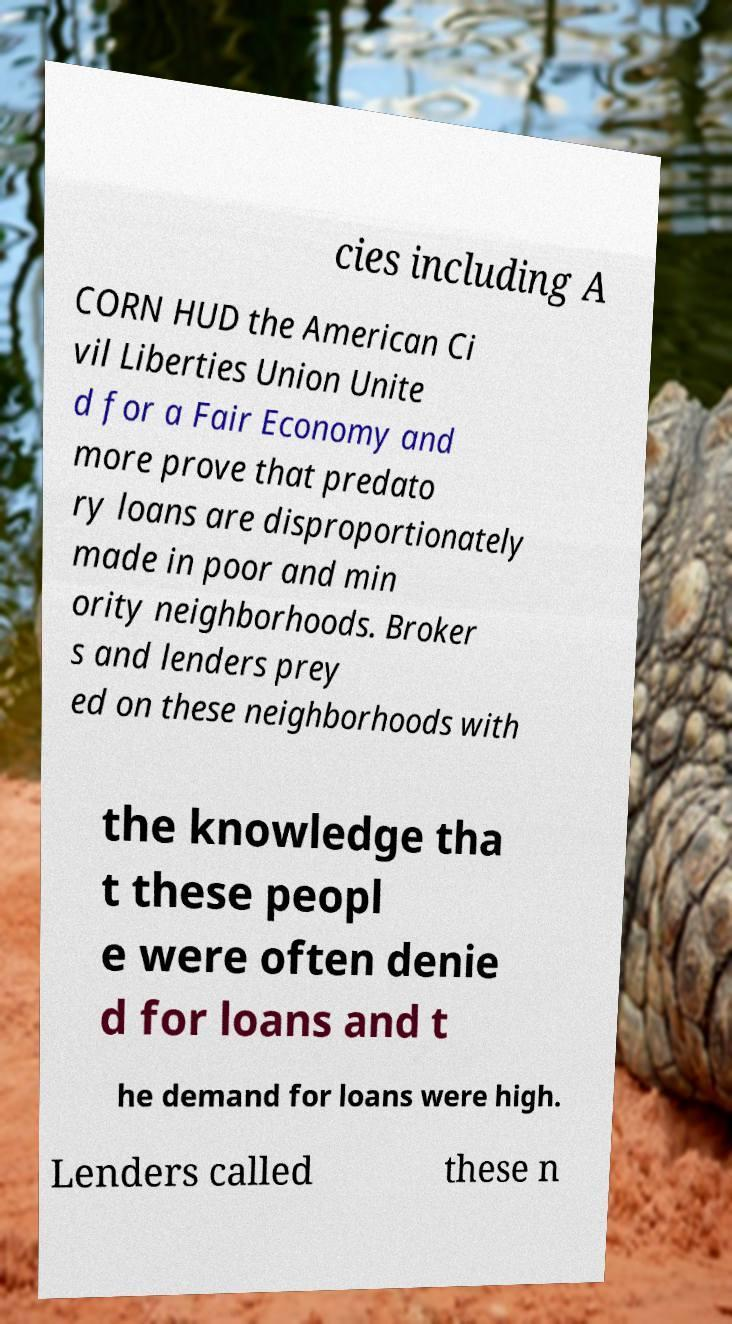There's text embedded in this image that I need extracted. Can you transcribe it verbatim? cies including A CORN HUD the American Ci vil Liberties Union Unite d for a Fair Economy and more prove that predato ry loans are disproportionately made in poor and min ority neighborhoods. Broker s and lenders prey ed on these neighborhoods with the knowledge tha t these peopl e were often denie d for loans and t he demand for loans were high. Lenders called these n 